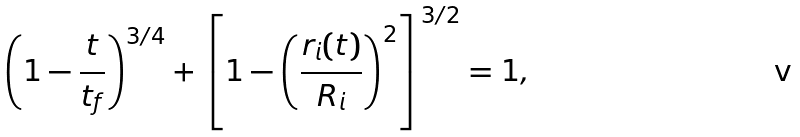Convert formula to latex. <formula><loc_0><loc_0><loc_500><loc_500>\left ( 1 - \frac { t } { t _ { f } } \right ) ^ { 3 / 4 } + \left [ 1 - \left ( \frac { r _ { i } ( t ) } { R _ { i } } \right ) ^ { 2 } \right ] ^ { 3 / 2 } = 1 ,</formula> 